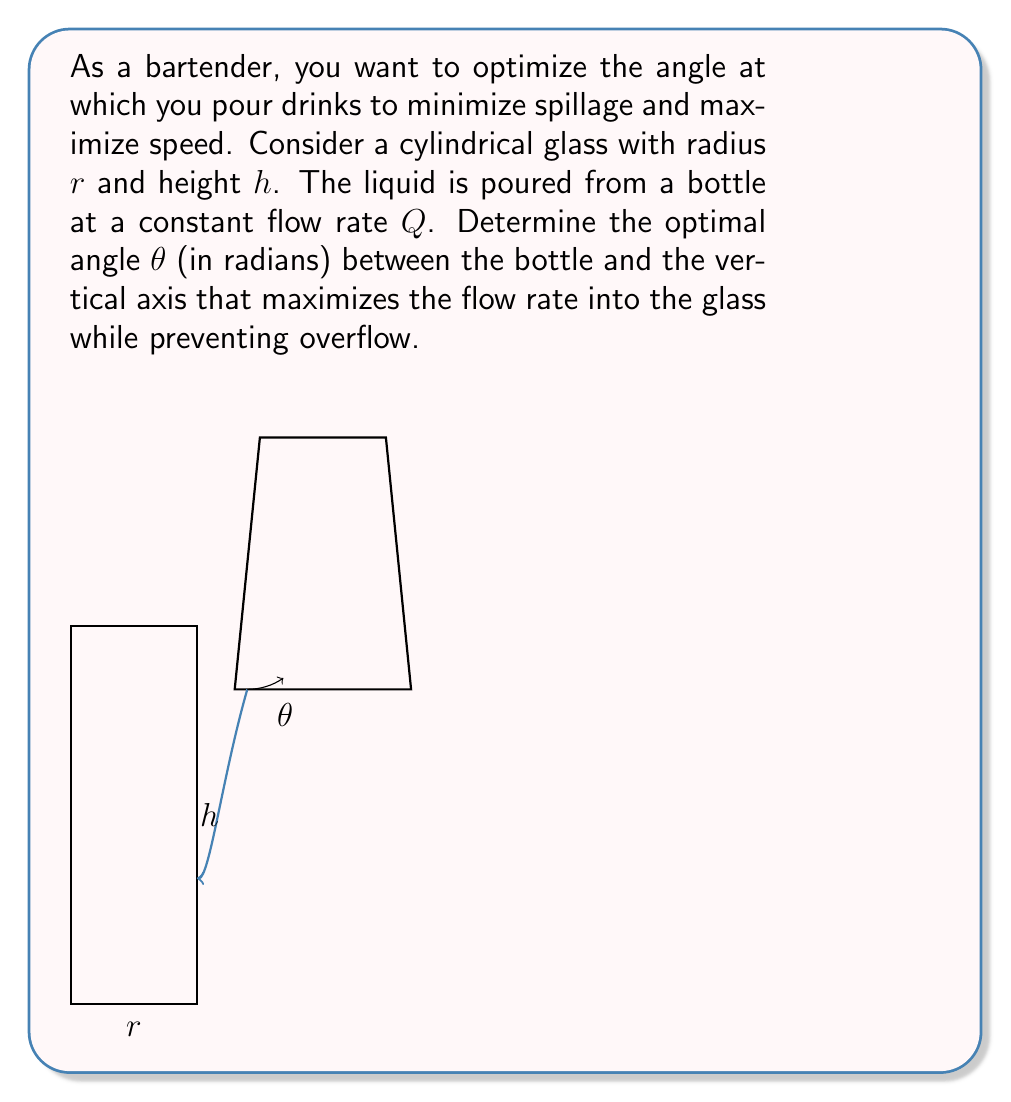Give your solution to this math problem. Let's approach this problem step-by-step:

1) The cross-sectional area of the stream of liquid can be approximated as an ellipse. The major axis of this ellipse is perpendicular to the direction of flow, and its length is proportional to $\cos\theta$.

2) The velocity of the liquid along the direction of flow is proportional to $\sin\theta$ due to gravity.

3) The volumetric flow rate into the glass is proportional to the product of the cross-sectional area and the velocity:

   $$Q \propto \cos\theta \cdot \sin\theta = \frac{1}{2}\sin(2\theta)$$

4) To find the maximum flow rate, we need to maximize $\sin(2\theta)$. This occurs when $2\theta = \frac{\pi}{2}$, or $\theta = \frac{\pi}{4}$.

5) However, we also need to consider the height of the glass. If the pour angle is too steep, the liquid might miss the glass or cause splashing.

6) The maximum height the liquid can reach in the glass without overflow is $h$. The horizontal distance the liquid travels is related to this height by:

   $$\text{Horizontal distance} = h \cdot \tan\theta$$

7) To ensure the liquid enters the glass, this distance should be less than or equal to the radius of the glass:

   $$h \cdot \tan\theta \leq r$$

8) Solving for $\theta$:

   $$\theta \leq \arctan(\frac{r}{h})$$

9) The optimal angle is the smaller of $\frac{\pi}{4}$ and $\arctan(\frac{r}{h})$:

   $$\theta_{\text{optimal}} = \min(\frac{\pi}{4}, \arctan(\frac{r}{h}))$$

This angle maximizes the flow rate while ensuring the liquid enters the glass without overflow.
Answer: $\theta_{\text{optimal}} = \min(\frac{\pi}{4}, \arctan(\frac{r}{h}))$ 